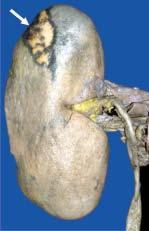does the spleen lie internally?
Answer the question using a single word or phrase. No 